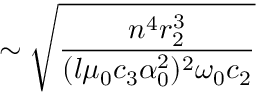Convert formula to latex. <formula><loc_0><loc_0><loc_500><loc_500>\sim \sqrt { \frac { n ^ { 4 } r _ { 2 } ^ { 3 } } { ( l \mu _ { 0 } c _ { 3 } \alpha _ { 0 } ^ { 2 } ) ^ { 2 } \omega _ { 0 } c _ { 2 } } }</formula> 